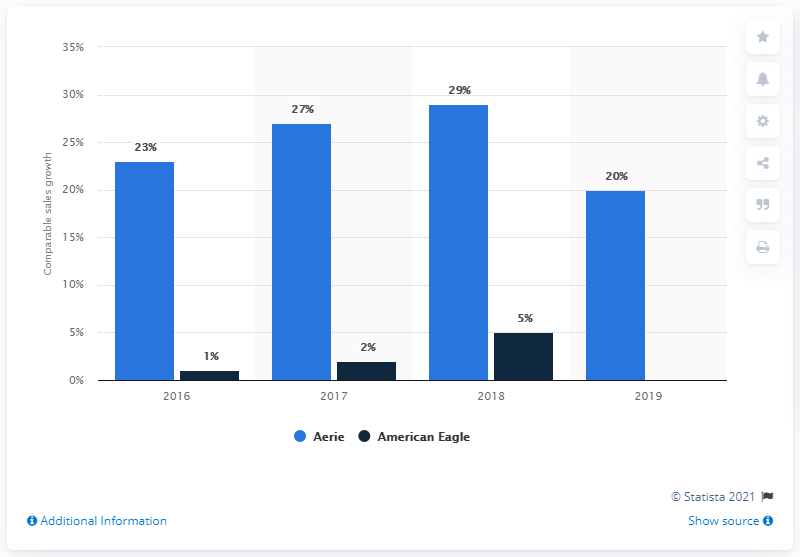What does light blue represent on the graph? On the graph, the light blue represents the comparative sales growth percentage for the Aerie brand over the years 2016 to 2019. 